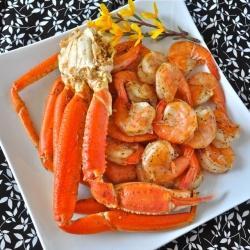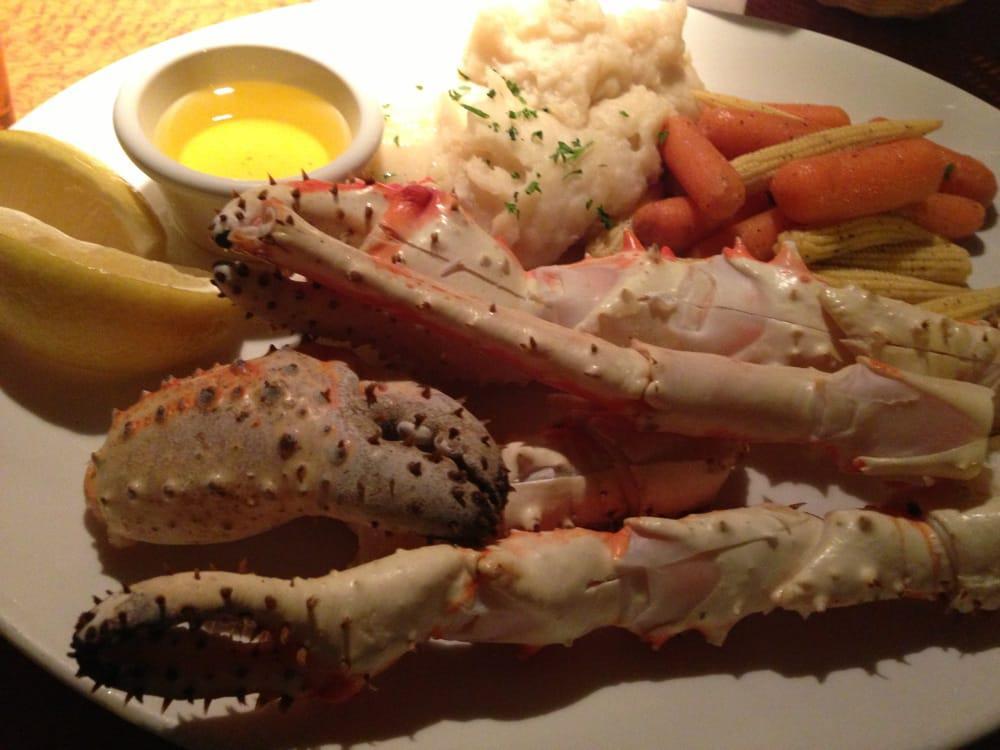The first image is the image on the left, the second image is the image on the right. Examine the images to the left and right. Is the description "Something yellow is in a round container behind crab legs in one image." accurate? Answer yes or no. Yes. The first image is the image on the left, the second image is the image on the right. Considering the images on both sides, is "The crabs in both of the images sit in dishes." valid? Answer yes or no. Yes. 